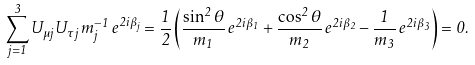Convert formula to latex. <formula><loc_0><loc_0><loc_500><loc_500>\sum _ { j = 1 } ^ { 3 } U _ { \mu j } U _ { \tau j } \, m _ { j } ^ { - 1 } \, e ^ { 2 i \beta _ { j } } = \frac { 1 } { 2 } \left ( \frac { \sin ^ { 2 } \theta } { m _ { 1 } } \, e ^ { 2 i \beta _ { 1 } } + \frac { \cos ^ { 2 } \theta } { m _ { 2 } } \, e ^ { 2 i \beta _ { 2 } } - \frac { 1 } { m _ { 3 } } \, e ^ { 2 i \beta _ { 3 } } \right ) = 0 .</formula> 